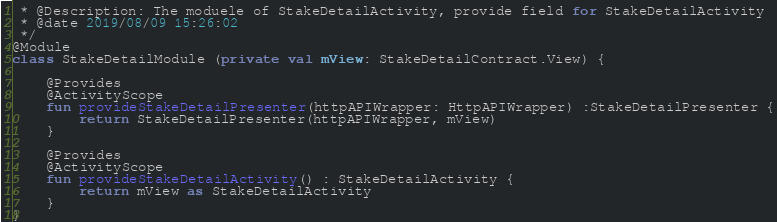<code> <loc_0><loc_0><loc_500><loc_500><_Kotlin_> * @Description: The moduele of StakeDetailActivity, provide field for StakeDetailActivity
 * @date 2019/08/09 15:26:02
 */
@Module
class StakeDetailModule (private val mView: StakeDetailContract.View) {

    @Provides
    @ActivityScope
    fun provideStakeDetailPresenter(httpAPIWrapper: HttpAPIWrapper) :StakeDetailPresenter {
        return StakeDetailPresenter(httpAPIWrapper, mView)
    }

    @Provides
    @ActivityScope
    fun provideStakeDetailActivity() : StakeDetailActivity {
        return mView as StakeDetailActivity
    }
}</code> 